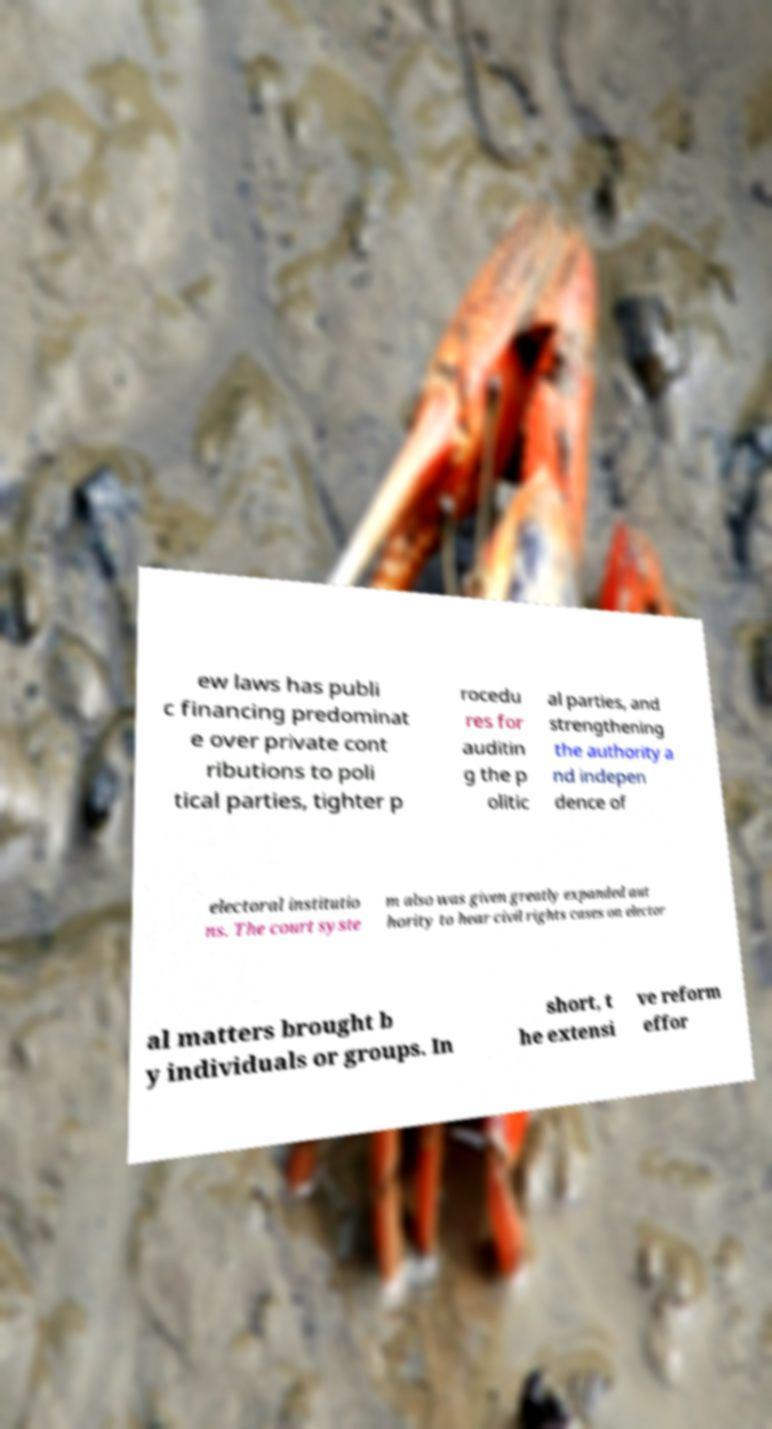I need the written content from this picture converted into text. Can you do that? ew laws has publi c financing predominat e over private cont ributions to poli tical parties, tighter p rocedu res for auditin g the p olitic al parties, and strengthening the authority a nd indepen dence of electoral institutio ns. The court syste m also was given greatly expanded aut hority to hear civil rights cases on elector al matters brought b y individuals or groups. In short, t he extensi ve reform effor 